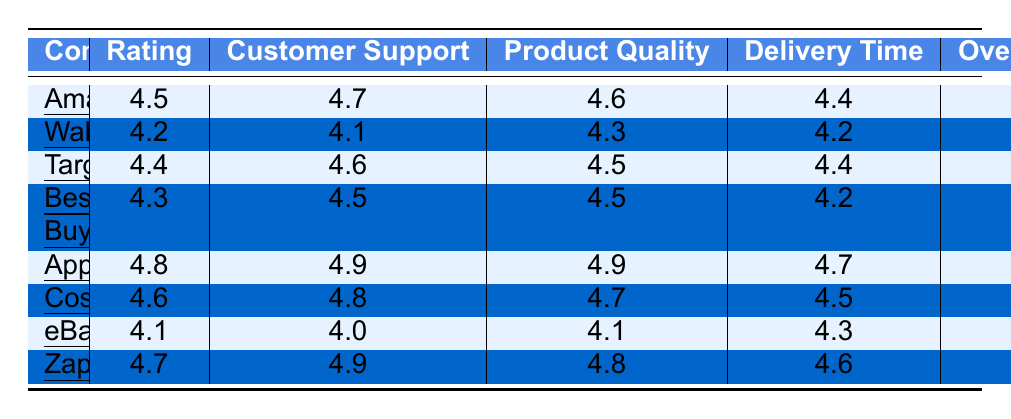What is the highest Customer Satisfaction Rating among the companies? By scanning the Ratings column, Apple has the highest rating at 4.8.
Answer: 4.8 Which company has the best score in Customer Support? Looking at the Customer Support column, Apple and Zappos both have the highest score of 4.9.
Answer: Apple and Zappos What is the average Overall Satisfaction rating across all companies? Adding the Overall Satisfaction ratings (4.5 + 4.2 + 4.4 + 4.3 + 4.8 + 4.6 + 4.1 + 4.7 = 34.6) and dividing by the number of companies (8), the average is 34.6/8 = 4.325.
Answer: 4.325 Which company ranks second in terms of Overall Satisfaction? By reviewing the Overall Satisfaction scores, Zappos (4.7) ranks second after Apple (4.8).
Answer: Zappos Is Walmart's Delivery Time rating higher than eBay's? Comparing the Delivery Time ratings, Walmart has 4.2 and eBay has 4.3. Since 4.2 is less than 4.3, Walmart's rating is not higher.
Answer: No What is the difference between the Customer Support ratings of Apple and Walmart? Apple has a Customer Support rating of 4.9 and Walmart has 4.1. The difference is 4.9 - 4.1 = 0.8.
Answer: 0.8 Which company has the lowest rating in Product Quality? Evaluating the Product Quality ratings, eBay has the lowest score of 4.1.
Answer: eBay How many companies have an Overall Satisfaction rating of 4.5 or higher? Counting the companies with an Overall Satisfaction rating of 4.5 or above: Amazon (4.5), Apple (4.8), Costco (4.6), and Zappos (4.7) gives a total of 4.
Answer: 4 What is the highest Delivery Time rating, and which company holds it? The highest Delivery Time rating is 4.7, which is held by Apple.
Answer: 4.7 (Apple) Which company has a better Customer Support rating, Costco or Best Buy? Comparing the Customer Support ratings, Costco has 4.8 and Best Buy has 4.5. Since 4.8 > 4.5, Costco is better.
Answer: Costco 